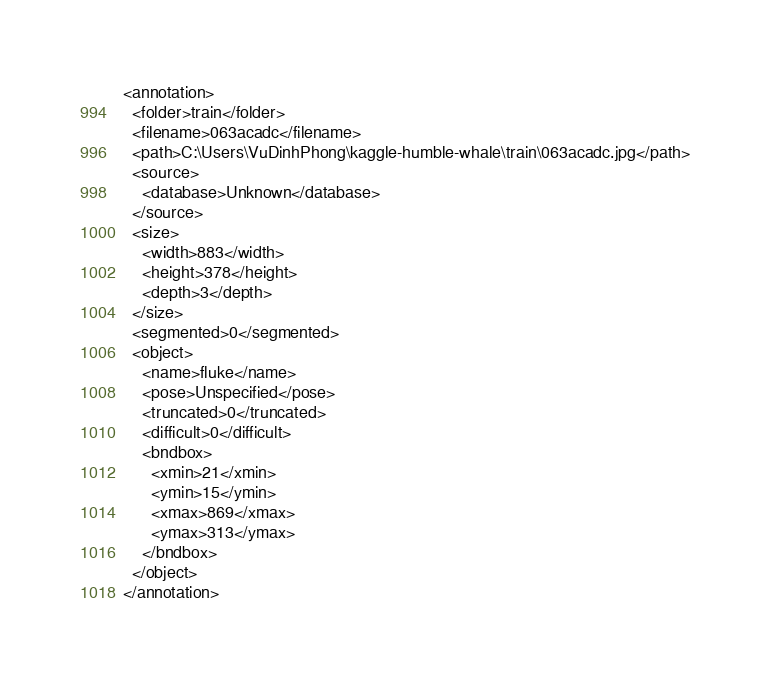Convert code to text. <code><loc_0><loc_0><loc_500><loc_500><_XML_><annotation>
  <folder>train</folder>
  <filename>063acadc</filename>
  <path>C:\Users\VuDinhPhong\kaggle-humble-whale\train\063acadc.jpg</path>
  <source>
    <database>Unknown</database>
  </source>
  <size>
    <width>883</width>
    <height>378</height>
    <depth>3</depth>
  </size>
  <segmented>0</segmented>
  <object>
    <name>fluke</name>
    <pose>Unspecified</pose>
    <truncated>0</truncated>
    <difficult>0</difficult>
    <bndbox>
      <xmin>21</xmin>
      <ymin>15</ymin>
      <xmax>869</xmax>
      <ymax>313</ymax>
    </bndbox>
  </object>
</annotation>
</code> 